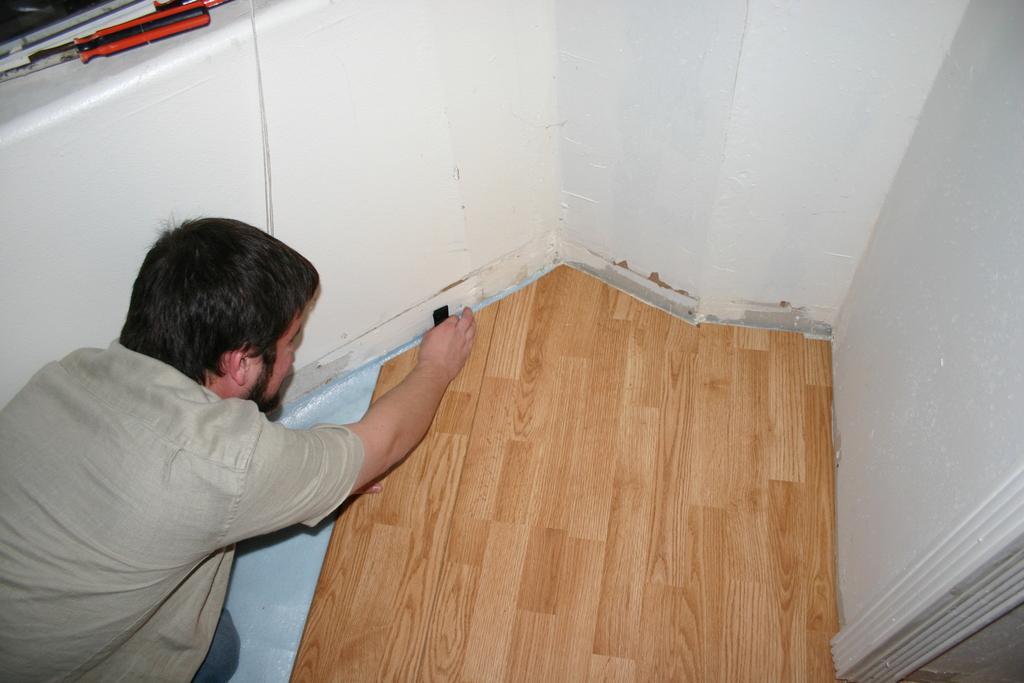In one or two sentences, can you explain what this image depicts? A person is present at the left. There is a wooden surface. There are walls surrounded. 